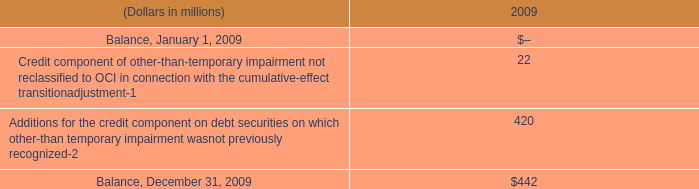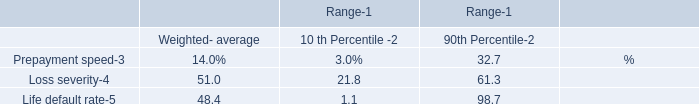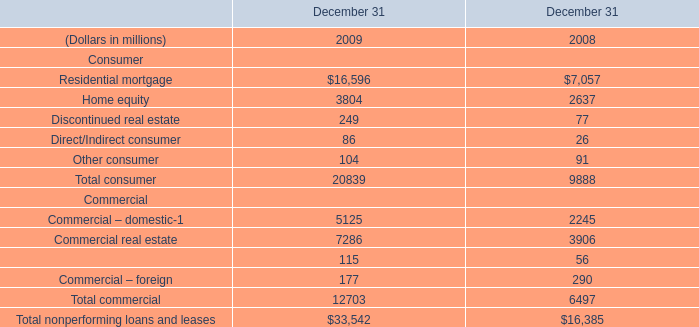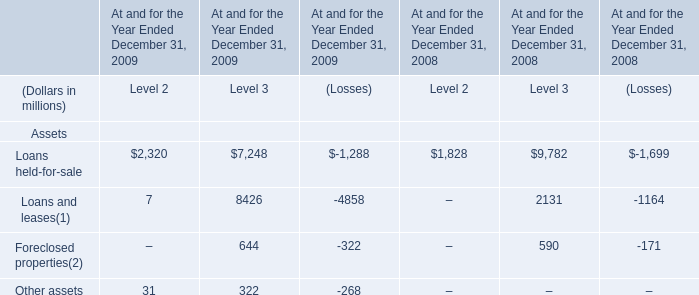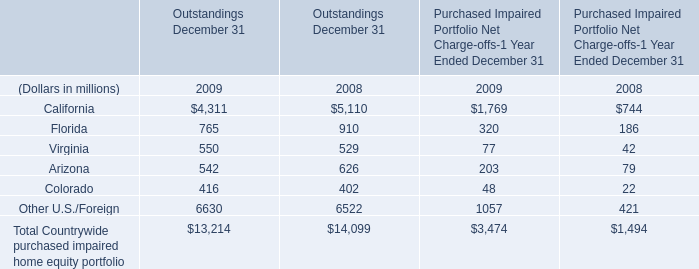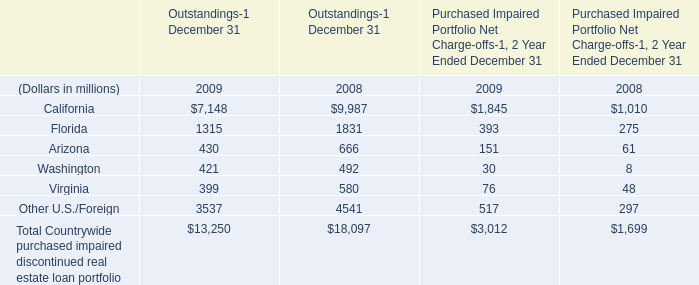What's the sum of Commercial real estate Commercial of December 31 2008, Other U.S./Foreign of Outstandings December 31 2009, and California of Outstandings December 31 2009 ? 
Computations: ((3906.0 + 6630.0) + 1769.0)
Answer: 12305.0. 